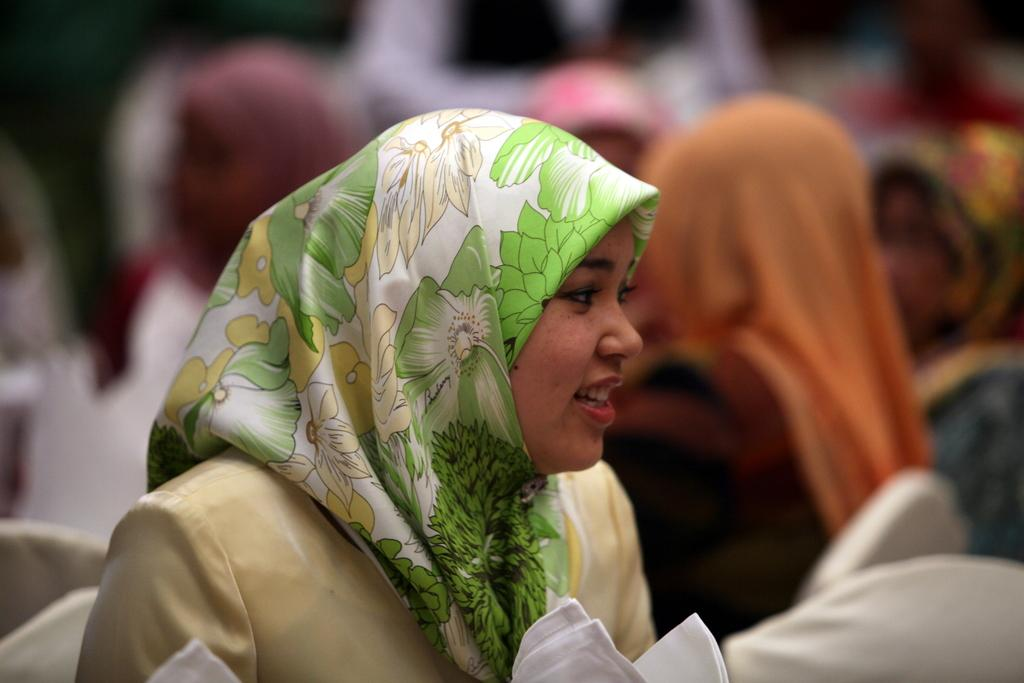Who is present in the image? There is a woman in the image. What is the woman doing in the image? The woman is smiling in the image. What is the woman wearing on her head? The woman is wearing a scarf on her head. What color are the clothes visible in the image? The clothes visible in the image are white. How is the background of the image depicted? The background of the image has a blurred view. How many people are present in the image? There are people in the image, but the exact number is not specified. What is the cause of death for the woman in the image? There is no indication of death in the image, as the woman is smiling and there is no mention of any tragic event. 